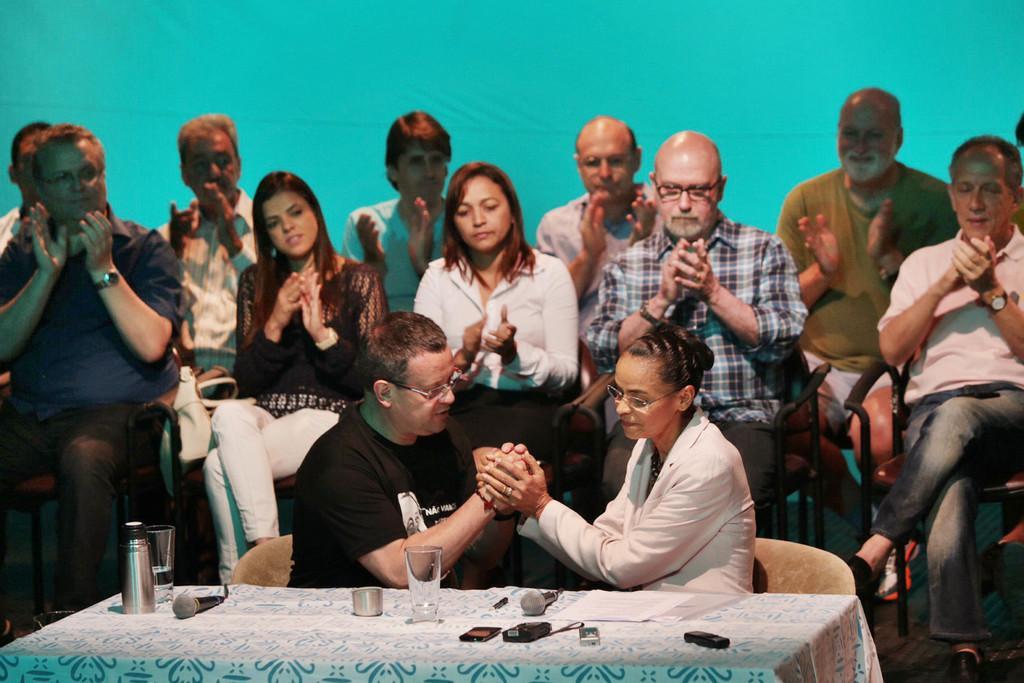Describe this image in one or two sentences. In this picture we can see a group of people sitting and clapping their hands and in front of them one man and woman holding their hands and sitting on chairs and in front of them on table we have mic, glass with water in it, mobile, remote, papers and in background we can see wall. 